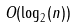<formula> <loc_0><loc_0><loc_500><loc_500>O ( \log _ { 2 } ( n ) )</formula> 